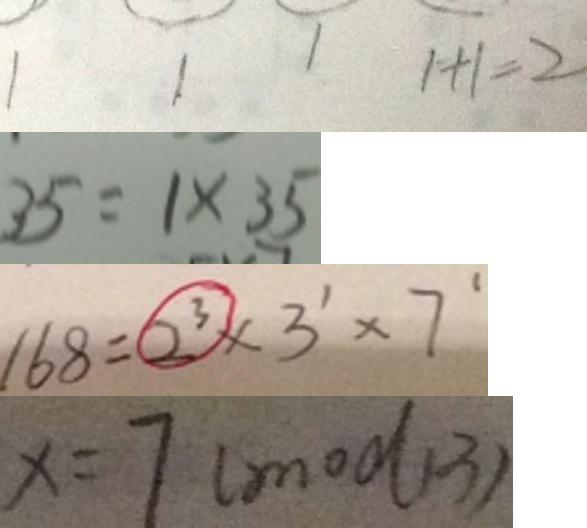<formula> <loc_0><loc_0><loc_500><loc_500>1 1 1 1 + 1 = 2 
 3 5 = 1 \times 3 5 
 1 6 8 = 2 ^ { 3 } \times 3 ^ { 1 } \times 7 ^ { 1 } 
 x = 7 ( m o d 1 3 )</formula> 